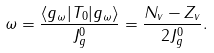Convert formula to latex. <formula><loc_0><loc_0><loc_500><loc_500>\omega = \frac { \langle g _ { \omega } | T _ { 0 } | g _ { \omega } \rangle } { J _ { g } ^ { 0 } } = \frac { N _ { v } - Z _ { v } } { 2 J _ { g } ^ { 0 } } .</formula> 